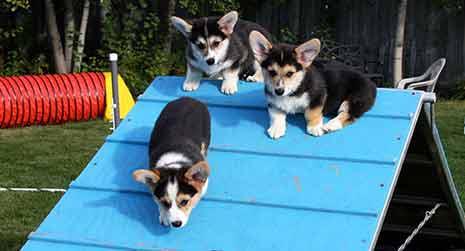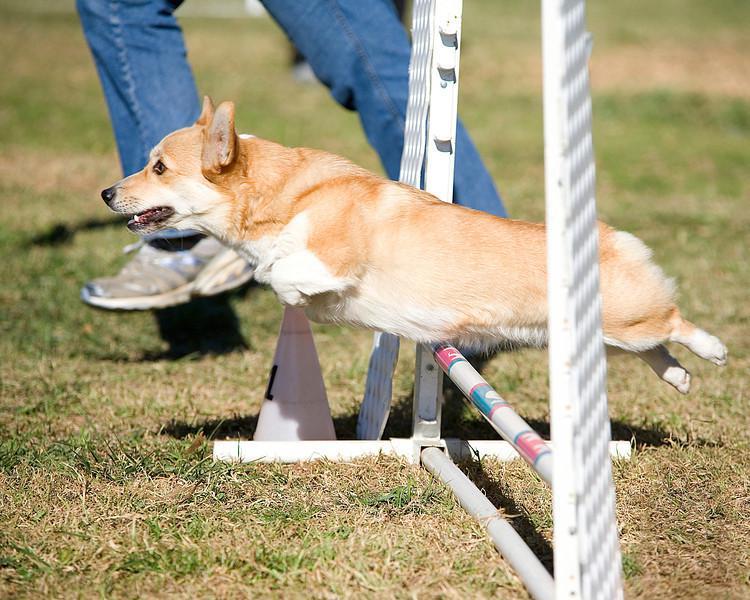The first image is the image on the left, the second image is the image on the right. Analyze the images presented: Is the assertion "The dog in the right image is inside of a small inflatable swimming pool." valid? Answer yes or no. No. The first image is the image on the left, the second image is the image on the right. Analyze the images presented: Is the assertion "No less than one dog is in mid air jumping over a hurdle" valid? Answer yes or no. Yes. 